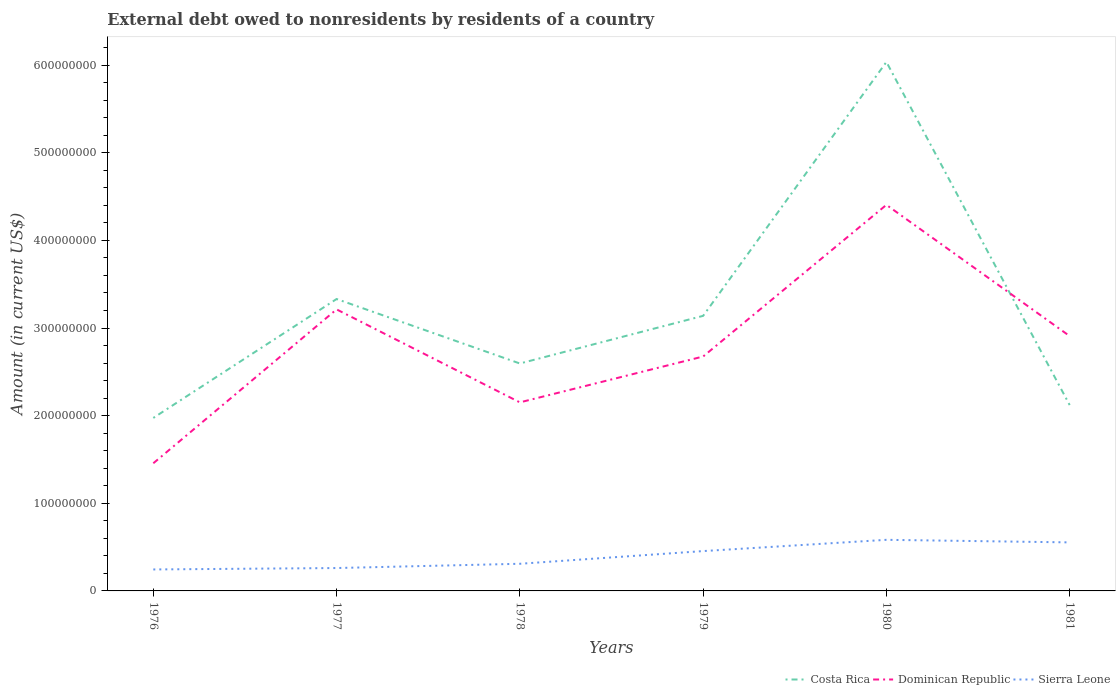Does the line corresponding to Dominican Republic intersect with the line corresponding to Costa Rica?
Keep it short and to the point. Yes. Is the number of lines equal to the number of legend labels?
Your response must be concise. Yes. Across all years, what is the maximum external debt owed by residents in Costa Rica?
Your answer should be compact. 1.97e+08. In which year was the external debt owed by residents in Costa Rica maximum?
Your answer should be compact. 1976. What is the total external debt owed by residents in Sierra Leone in the graph?
Provide a short and direct response. -1.28e+07. What is the difference between the highest and the second highest external debt owed by residents in Dominican Republic?
Provide a short and direct response. 2.95e+08. How many years are there in the graph?
Provide a short and direct response. 6. What is the difference between two consecutive major ticks on the Y-axis?
Your response must be concise. 1.00e+08. Are the values on the major ticks of Y-axis written in scientific E-notation?
Provide a short and direct response. No. Does the graph contain any zero values?
Offer a very short reply. No. Does the graph contain grids?
Give a very brief answer. No. How many legend labels are there?
Your answer should be very brief. 3. How are the legend labels stacked?
Provide a succinct answer. Horizontal. What is the title of the graph?
Provide a succinct answer. External debt owed to nonresidents by residents of a country. Does "Barbados" appear as one of the legend labels in the graph?
Provide a succinct answer. No. What is the label or title of the Y-axis?
Provide a short and direct response. Amount (in current US$). What is the Amount (in current US$) of Costa Rica in 1976?
Keep it short and to the point. 1.97e+08. What is the Amount (in current US$) in Dominican Republic in 1976?
Make the answer very short. 1.46e+08. What is the Amount (in current US$) of Sierra Leone in 1976?
Provide a short and direct response. 2.45e+07. What is the Amount (in current US$) in Costa Rica in 1977?
Offer a terse response. 3.33e+08. What is the Amount (in current US$) in Dominican Republic in 1977?
Your response must be concise. 3.21e+08. What is the Amount (in current US$) in Sierra Leone in 1977?
Make the answer very short. 2.61e+07. What is the Amount (in current US$) of Costa Rica in 1978?
Offer a very short reply. 2.60e+08. What is the Amount (in current US$) of Dominican Republic in 1978?
Keep it short and to the point. 2.15e+08. What is the Amount (in current US$) of Sierra Leone in 1978?
Ensure brevity in your answer.  3.10e+07. What is the Amount (in current US$) of Costa Rica in 1979?
Provide a succinct answer. 3.14e+08. What is the Amount (in current US$) in Dominican Republic in 1979?
Give a very brief answer. 2.68e+08. What is the Amount (in current US$) of Sierra Leone in 1979?
Your answer should be very brief. 4.55e+07. What is the Amount (in current US$) in Costa Rica in 1980?
Make the answer very short. 6.04e+08. What is the Amount (in current US$) of Dominican Republic in 1980?
Keep it short and to the point. 4.41e+08. What is the Amount (in current US$) in Sierra Leone in 1980?
Your response must be concise. 5.83e+07. What is the Amount (in current US$) in Costa Rica in 1981?
Your answer should be very brief. 2.12e+08. What is the Amount (in current US$) in Dominican Republic in 1981?
Give a very brief answer. 2.91e+08. What is the Amount (in current US$) of Sierra Leone in 1981?
Ensure brevity in your answer.  5.54e+07. Across all years, what is the maximum Amount (in current US$) in Costa Rica?
Offer a very short reply. 6.04e+08. Across all years, what is the maximum Amount (in current US$) of Dominican Republic?
Your answer should be compact. 4.41e+08. Across all years, what is the maximum Amount (in current US$) in Sierra Leone?
Your response must be concise. 5.83e+07. Across all years, what is the minimum Amount (in current US$) of Costa Rica?
Make the answer very short. 1.97e+08. Across all years, what is the minimum Amount (in current US$) in Dominican Republic?
Your answer should be compact. 1.46e+08. Across all years, what is the minimum Amount (in current US$) of Sierra Leone?
Make the answer very short. 2.45e+07. What is the total Amount (in current US$) of Costa Rica in the graph?
Keep it short and to the point. 1.92e+09. What is the total Amount (in current US$) of Dominican Republic in the graph?
Provide a short and direct response. 1.68e+09. What is the total Amount (in current US$) of Sierra Leone in the graph?
Your answer should be very brief. 2.41e+08. What is the difference between the Amount (in current US$) of Costa Rica in 1976 and that in 1977?
Offer a terse response. -1.36e+08. What is the difference between the Amount (in current US$) in Dominican Republic in 1976 and that in 1977?
Your answer should be compact. -1.76e+08. What is the difference between the Amount (in current US$) in Sierra Leone in 1976 and that in 1977?
Give a very brief answer. -1.61e+06. What is the difference between the Amount (in current US$) of Costa Rica in 1976 and that in 1978?
Ensure brevity in your answer.  -6.21e+07. What is the difference between the Amount (in current US$) of Dominican Republic in 1976 and that in 1978?
Provide a short and direct response. -6.95e+07. What is the difference between the Amount (in current US$) of Sierra Leone in 1976 and that in 1978?
Your response must be concise. -6.47e+06. What is the difference between the Amount (in current US$) in Costa Rica in 1976 and that in 1979?
Offer a terse response. -1.16e+08. What is the difference between the Amount (in current US$) of Dominican Republic in 1976 and that in 1979?
Your answer should be compact. -1.22e+08. What is the difference between the Amount (in current US$) of Sierra Leone in 1976 and that in 1979?
Make the answer very short. -2.10e+07. What is the difference between the Amount (in current US$) of Costa Rica in 1976 and that in 1980?
Provide a short and direct response. -4.06e+08. What is the difference between the Amount (in current US$) of Dominican Republic in 1976 and that in 1980?
Give a very brief answer. -2.95e+08. What is the difference between the Amount (in current US$) in Sierra Leone in 1976 and that in 1980?
Keep it short and to the point. -3.38e+07. What is the difference between the Amount (in current US$) in Costa Rica in 1976 and that in 1981?
Give a very brief answer. -1.47e+07. What is the difference between the Amount (in current US$) in Dominican Republic in 1976 and that in 1981?
Offer a very short reply. -1.45e+08. What is the difference between the Amount (in current US$) in Sierra Leone in 1976 and that in 1981?
Provide a succinct answer. -3.09e+07. What is the difference between the Amount (in current US$) of Costa Rica in 1977 and that in 1978?
Ensure brevity in your answer.  7.36e+07. What is the difference between the Amount (in current US$) in Dominican Republic in 1977 and that in 1978?
Give a very brief answer. 1.06e+08. What is the difference between the Amount (in current US$) in Sierra Leone in 1977 and that in 1978?
Keep it short and to the point. -4.86e+06. What is the difference between the Amount (in current US$) of Costa Rica in 1977 and that in 1979?
Keep it short and to the point. 1.92e+07. What is the difference between the Amount (in current US$) in Dominican Republic in 1977 and that in 1979?
Offer a terse response. 5.38e+07. What is the difference between the Amount (in current US$) in Sierra Leone in 1977 and that in 1979?
Make the answer very short. -1.93e+07. What is the difference between the Amount (in current US$) of Costa Rica in 1977 and that in 1980?
Your answer should be very brief. -2.71e+08. What is the difference between the Amount (in current US$) of Dominican Republic in 1977 and that in 1980?
Provide a short and direct response. -1.19e+08. What is the difference between the Amount (in current US$) in Sierra Leone in 1977 and that in 1980?
Your answer should be compact. -3.22e+07. What is the difference between the Amount (in current US$) of Costa Rica in 1977 and that in 1981?
Offer a terse response. 1.21e+08. What is the difference between the Amount (in current US$) of Dominican Republic in 1977 and that in 1981?
Keep it short and to the point. 3.05e+07. What is the difference between the Amount (in current US$) in Sierra Leone in 1977 and that in 1981?
Make the answer very short. -2.93e+07. What is the difference between the Amount (in current US$) of Costa Rica in 1978 and that in 1979?
Make the answer very short. -5.44e+07. What is the difference between the Amount (in current US$) in Dominican Republic in 1978 and that in 1979?
Provide a succinct answer. -5.23e+07. What is the difference between the Amount (in current US$) in Sierra Leone in 1978 and that in 1979?
Your response must be concise. -1.45e+07. What is the difference between the Amount (in current US$) in Costa Rica in 1978 and that in 1980?
Provide a short and direct response. -3.44e+08. What is the difference between the Amount (in current US$) of Dominican Republic in 1978 and that in 1980?
Keep it short and to the point. -2.25e+08. What is the difference between the Amount (in current US$) in Sierra Leone in 1978 and that in 1980?
Give a very brief answer. -2.73e+07. What is the difference between the Amount (in current US$) of Costa Rica in 1978 and that in 1981?
Make the answer very short. 4.74e+07. What is the difference between the Amount (in current US$) of Dominican Republic in 1978 and that in 1981?
Your answer should be very brief. -7.56e+07. What is the difference between the Amount (in current US$) of Sierra Leone in 1978 and that in 1981?
Provide a succinct answer. -2.44e+07. What is the difference between the Amount (in current US$) in Costa Rica in 1979 and that in 1980?
Keep it short and to the point. -2.90e+08. What is the difference between the Amount (in current US$) in Dominican Republic in 1979 and that in 1980?
Provide a succinct answer. -1.73e+08. What is the difference between the Amount (in current US$) of Sierra Leone in 1979 and that in 1980?
Ensure brevity in your answer.  -1.28e+07. What is the difference between the Amount (in current US$) in Costa Rica in 1979 and that in 1981?
Your answer should be very brief. 1.02e+08. What is the difference between the Amount (in current US$) of Dominican Republic in 1979 and that in 1981?
Give a very brief answer. -2.33e+07. What is the difference between the Amount (in current US$) in Sierra Leone in 1979 and that in 1981?
Keep it short and to the point. -9.92e+06. What is the difference between the Amount (in current US$) in Costa Rica in 1980 and that in 1981?
Give a very brief answer. 3.92e+08. What is the difference between the Amount (in current US$) in Dominican Republic in 1980 and that in 1981?
Your answer should be compact. 1.50e+08. What is the difference between the Amount (in current US$) in Sierra Leone in 1980 and that in 1981?
Your response must be concise. 2.93e+06. What is the difference between the Amount (in current US$) in Costa Rica in 1976 and the Amount (in current US$) in Dominican Republic in 1977?
Provide a short and direct response. -1.24e+08. What is the difference between the Amount (in current US$) in Costa Rica in 1976 and the Amount (in current US$) in Sierra Leone in 1977?
Offer a terse response. 1.71e+08. What is the difference between the Amount (in current US$) in Dominican Republic in 1976 and the Amount (in current US$) in Sierra Leone in 1977?
Keep it short and to the point. 1.20e+08. What is the difference between the Amount (in current US$) in Costa Rica in 1976 and the Amount (in current US$) in Dominican Republic in 1978?
Provide a succinct answer. -1.78e+07. What is the difference between the Amount (in current US$) in Costa Rica in 1976 and the Amount (in current US$) in Sierra Leone in 1978?
Make the answer very short. 1.66e+08. What is the difference between the Amount (in current US$) of Dominican Republic in 1976 and the Amount (in current US$) of Sierra Leone in 1978?
Provide a succinct answer. 1.15e+08. What is the difference between the Amount (in current US$) in Costa Rica in 1976 and the Amount (in current US$) in Dominican Republic in 1979?
Provide a succinct answer. -7.01e+07. What is the difference between the Amount (in current US$) in Costa Rica in 1976 and the Amount (in current US$) in Sierra Leone in 1979?
Keep it short and to the point. 1.52e+08. What is the difference between the Amount (in current US$) of Dominican Republic in 1976 and the Amount (in current US$) of Sierra Leone in 1979?
Give a very brief answer. 1.00e+08. What is the difference between the Amount (in current US$) in Costa Rica in 1976 and the Amount (in current US$) in Dominican Republic in 1980?
Provide a succinct answer. -2.43e+08. What is the difference between the Amount (in current US$) in Costa Rica in 1976 and the Amount (in current US$) in Sierra Leone in 1980?
Offer a very short reply. 1.39e+08. What is the difference between the Amount (in current US$) in Dominican Republic in 1976 and the Amount (in current US$) in Sierra Leone in 1980?
Ensure brevity in your answer.  8.74e+07. What is the difference between the Amount (in current US$) of Costa Rica in 1976 and the Amount (in current US$) of Dominican Republic in 1981?
Provide a succinct answer. -9.34e+07. What is the difference between the Amount (in current US$) in Costa Rica in 1976 and the Amount (in current US$) in Sierra Leone in 1981?
Provide a short and direct response. 1.42e+08. What is the difference between the Amount (in current US$) in Dominican Republic in 1976 and the Amount (in current US$) in Sierra Leone in 1981?
Offer a terse response. 9.03e+07. What is the difference between the Amount (in current US$) of Costa Rica in 1977 and the Amount (in current US$) of Dominican Republic in 1978?
Your response must be concise. 1.18e+08. What is the difference between the Amount (in current US$) of Costa Rica in 1977 and the Amount (in current US$) of Sierra Leone in 1978?
Provide a short and direct response. 3.02e+08. What is the difference between the Amount (in current US$) in Dominican Republic in 1977 and the Amount (in current US$) in Sierra Leone in 1978?
Offer a terse response. 2.90e+08. What is the difference between the Amount (in current US$) of Costa Rica in 1977 and the Amount (in current US$) of Dominican Republic in 1979?
Your answer should be compact. 6.56e+07. What is the difference between the Amount (in current US$) of Costa Rica in 1977 and the Amount (in current US$) of Sierra Leone in 1979?
Offer a terse response. 2.88e+08. What is the difference between the Amount (in current US$) in Dominican Republic in 1977 and the Amount (in current US$) in Sierra Leone in 1979?
Give a very brief answer. 2.76e+08. What is the difference between the Amount (in current US$) of Costa Rica in 1977 and the Amount (in current US$) of Dominican Republic in 1980?
Make the answer very short. -1.07e+08. What is the difference between the Amount (in current US$) of Costa Rica in 1977 and the Amount (in current US$) of Sierra Leone in 1980?
Your answer should be very brief. 2.75e+08. What is the difference between the Amount (in current US$) in Dominican Republic in 1977 and the Amount (in current US$) in Sierra Leone in 1980?
Give a very brief answer. 2.63e+08. What is the difference between the Amount (in current US$) in Costa Rica in 1977 and the Amount (in current US$) in Dominican Republic in 1981?
Your response must be concise. 4.23e+07. What is the difference between the Amount (in current US$) in Costa Rica in 1977 and the Amount (in current US$) in Sierra Leone in 1981?
Provide a succinct answer. 2.78e+08. What is the difference between the Amount (in current US$) of Dominican Republic in 1977 and the Amount (in current US$) of Sierra Leone in 1981?
Provide a short and direct response. 2.66e+08. What is the difference between the Amount (in current US$) in Costa Rica in 1978 and the Amount (in current US$) in Dominican Republic in 1979?
Offer a very short reply. -7.96e+06. What is the difference between the Amount (in current US$) of Costa Rica in 1978 and the Amount (in current US$) of Sierra Leone in 1979?
Your answer should be very brief. 2.14e+08. What is the difference between the Amount (in current US$) in Dominican Republic in 1978 and the Amount (in current US$) in Sierra Leone in 1979?
Your answer should be very brief. 1.70e+08. What is the difference between the Amount (in current US$) of Costa Rica in 1978 and the Amount (in current US$) of Dominican Republic in 1980?
Your response must be concise. -1.81e+08. What is the difference between the Amount (in current US$) in Costa Rica in 1978 and the Amount (in current US$) in Sierra Leone in 1980?
Offer a terse response. 2.01e+08. What is the difference between the Amount (in current US$) in Dominican Republic in 1978 and the Amount (in current US$) in Sierra Leone in 1980?
Provide a succinct answer. 1.57e+08. What is the difference between the Amount (in current US$) in Costa Rica in 1978 and the Amount (in current US$) in Dominican Republic in 1981?
Your response must be concise. -3.13e+07. What is the difference between the Amount (in current US$) of Costa Rica in 1978 and the Amount (in current US$) of Sierra Leone in 1981?
Provide a succinct answer. 2.04e+08. What is the difference between the Amount (in current US$) in Dominican Republic in 1978 and the Amount (in current US$) in Sierra Leone in 1981?
Offer a very short reply. 1.60e+08. What is the difference between the Amount (in current US$) of Costa Rica in 1979 and the Amount (in current US$) of Dominican Republic in 1980?
Offer a terse response. -1.27e+08. What is the difference between the Amount (in current US$) in Costa Rica in 1979 and the Amount (in current US$) in Sierra Leone in 1980?
Keep it short and to the point. 2.56e+08. What is the difference between the Amount (in current US$) in Dominican Republic in 1979 and the Amount (in current US$) in Sierra Leone in 1980?
Give a very brief answer. 2.09e+08. What is the difference between the Amount (in current US$) of Costa Rica in 1979 and the Amount (in current US$) of Dominican Republic in 1981?
Your answer should be compact. 2.31e+07. What is the difference between the Amount (in current US$) in Costa Rica in 1979 and the Amount (in current US$) in Sierra Leone in 1981?
Offer a terse response. 2.59e+08. What is the difference between the Amount (in current US$) in Dominican Republic in 1979 and the Amount (in current US$) in Sierra Leone in 1981?
Ensure brevity in your answer.  2.12e+08. What is the difference between the Amount (in current US$) in Costa Rica in 1980 and the Amount (in current US$) in Dominican Republic in 1981?
Offer a very short reply. 3.13e+08. What is the difference between the Amount (in current US$) in Costa Rica in 1980 and the Amount (in current US$) in Sierra Leone in 1981?
Offer a terse response. 5.48e+08. What is the difference between the Amount (in current US$) of Dominican Republic in 1980 and the Amount (in current US$) of Sierra Leone in 1981?
Offer a very short reply. 3.85e+08. What is the average Amount (in current US$) in Costa Rica per year?
Make the answer very short. 3.20e+08. What is the average Amount (in current US$) of Dominican Republic per year?
Make the answer very short. 2.80e+08. What is the average Amount (in current US$) of Sierra Leone per year?
Offer a terse response. 4.01e+07. In the year 1976, what is the difference between the Amount (in current US$) of Costa Rica and Amount (in current US$) of Dominican Republic?
Make the answer very short. 5.17e+07. In the year 1976, what is the difference between the Amount (in current US$) in Costa Rica and Amount (in current US$) in Sierra Leone?
Ensure brevity in your answer.  1.73e+08. In the year 1976, what is the difference between the Amount (in current US$) in Dominican Republic and Amount (in current US$) in Sierra Leone?
Keep it short and to the point. 1.21e+08. In the year 1977, what is the difference between the Amount (in current US$) of Costa Rica and Amount (in current US$) of Dominican Republic?
Ensure brevity in your answer.  1.18e+07. In the year 1977, what is the difference between the Amount (in current US$) of Costa Rica and Amount (in current US$) of Sierra Leone?
Make the answer very short. 3.07e+08. In the year 1977, what is the difference between the Amount (in current US$) of Dominican Republic and Amount (in current US$) of Sierra Leone?
Offer a very short reply. 2.95e+08. In the year 1978, what is the difference between the Amount (in current US$) of Costa Rica and Amount (in current US$) of Dominican Republic?
Offer a terse response. 4.44e+07. In the year 1978, what is the difference between the Amount (in current US$) of Costa Rica and Amount (in current US$) of Sierra Leone?
Keep it short and to the point. 2.29e+08. In the year 1978, what is the difference between the Amount (in current US$) in Dominican Republic and Amount (in current US$) in Sierra Leone?
Offer a terse response. 1.84e+08. In the year 1979, what is the difference between the Amount (in current US$) in Costa Rica and Amount (in current US$) in Dominican Republic?
Give a very brief answer. 4.64e+07. In the year 1979, what is the difference between the Amount (in current US$) of Costa Rica and Amount (in current US$) of Sierra Leone?
Your answer should be compact. 2.68e+08. In the year 1979, what is the difference between the Amount (in current US$) of Dominican Republic and Amount (in current US$) of Sierra Leone?
Keep it short and to the point. 2.22e+08. In the year 1980, what is the difference between the Amount (in current US$) of Costa Rica and Amount (in current US$) of Dominican Republic?
Give a very brief answer. 1.63e+08. In the year 1980, what is the difference between the Amount (in current US$) in Costa Rica and Amount (in current US$) in Sierra Leone?
Provide a succinct answer. 5.45e+08. In the year 1980, what is the difference between the Amount (in current US$) in Dominican Republic and Amount (in current US$) in Sierra Leone?
Your response must be concise. 3.82e+08. In the year 1981, what is the difference between the Amount (in current US$) in Costa Rica and Amount (in current US$) in Dominican Republic?
Give a very brief answer. -7.87e+07. In the year 1981, what is the difference between the Amount (in current US$) of Costa Rica and Amount (in current US$) of Sierra Leone?
Your answer should be compact. 1.57e+08. In the year 1981, what is the difference between the Amount (in current US$) of Dominican Republic and Amount (in current US$) of Sierra Leone?
Ensure brevity in your answer.  2.35e+08. What is the ratio of the Amount (in current US$) of Costa Rica in 1976 to that in 1977?
Offer a terse response. 0.59. What is the ratio of the Amount (in current US$) of Dominican Republic in 1976 to that in 1977?
Provide a short and direct response. 0.45. What is the ratio of the Amount (in current US$) in Sierra Leone in 1976 to that in 1977?
Provide a succinct answer. 0.94. What is the ratio of the Amount (in current US$) of Costa Rica in 1976 to that in 1978?
Give a very brief answer. 0.76. What is the ratio of the Amount (in current US$) of Dominican Republic in 1976 to that in 1978?
Provide a short and direct response. 0.68. What is the ratio of the Amount (in current US$) in Sierra Leone in 1976 to that in 1978?
Your answer should be very brief. 0.79. What is the ratio of the Amount (in current US$) in Costa Rica in 1976 to that in 1979?
Your answer should be compact. 0.63. What is the ratio of the Amount (in current US$) of Dominican Republic in 1976 to that in 1979?
Your answer should be compact. 0.54. What is the ratio of the Amount (in current US$) in Sierra Leone in 1976 to that in 1979?
Ensure brevity in your answer.  0.54. What is the ratio of the Amount (in current US$) of Costa Rica in 1976 to that in 1980?
Your answer should be compact. 0.33. What is the ratio of the Amount (in current US$) of Dominican Republic in 1976 to that in 1980?
Make the answer very short. 0.33. What is the ratio of the Amount (in current US$) in Sierra Leone in 1976 to that in 1980?
Give a very brief answer. 0.42. What is the ratio of the Amount (in current US$) in Costa Rica in 1976 to that in 1981?
Your answer should be compact. 0.93. What is the ratio of the Amount (in current US$) of Dominican Republic in 1976 to that in 1981?
Your response must be concise. 0.5. What is the ratio of the Amount (in current US$) of Sierra Leone in 1976 to that in 1981?
Offer a very short reply. 0.44. What is the ratio of the Amount (in current US$) of Costa Rica in 1977 to that in 1978?
Keep it short and to the point. 1.28. What is the ratio of the Amount (in current US$) of Dominican Republic in 1977 to that in 1978?
Offer a very short reply. 1.49. What is the ratio of the Amount (in current US$) of Sierra Leone in 1977 to that in 1978?
Offer a very short reply. 0.84. What is the ratio of the Amount (in current US$) in Costa Rica in 1977 to that in 1979?
Keep it short and to the point. 1.06. What is the ratio of the Amount (in current US$) in Dominican Republic in 1977 to that in 1979?
Offer a terse response. 1.2. What is the ratio of the Amount (in current US$) in Sierra Leone in 1977 to that in 1979?
Your response must be concise. 0.57. What is the ratio of the Amount (in current US$) in Costa Rica in 1977 to that in 1980?
Provide a succinct answer. 0.55. What is the ratio of the Amount (in current US$) of Dominican Republic in 1977 to that in 1980?
Offer a very short reply. 0.73. What is the ratio of the Amount (in current US$) in Sierra Leone in 1977 to that in 1980?
Provide a succinct answer. 0.45. What is the ratio of the Amount (in current US$) in Costa Rica in 1977 to that in 1981?
Make the answer very short. 1.57. What is the ratio of the Amount (in current US$) of Dominican Republic in 1977 to that in 1981?
Give a very brief answer. 1.1. What is the ratio of the Amount (in current US$) of Sierra Leone in 1977 to that in 1981?
Provide a succinct answer. 0.47. What is the ratio of the Amount (in current US$) in Costa Rica in 1978 to that in 1979?
Offer a very short reply. 0.83. What is the ratio of the Amount (in current US$) of Dominican Republic in 1978 to that in 1979?
Offer a very short reply. 0.8. What is the ratio of the Amount (in current US$) of Sierra Leone in 1978 to that in 1979?
Offer a terse response. 0.68. What is the ratio of the Amount (in current US$) of Costa Rica in 1978 to that in 1980?
Offer a terse response. 0.43. What is the ratio of the Amount (in current US$) of Dominican Republic in 1978 to that in 1980?
Your answer should be compact. 0.49. What is the ratio of the Amount (in current US$) in Sierra Leone in 1978 to that in 1980?
Make the answer very short. 0.53. What is the ratio of the Amount (in current US$) of Costa Rica in 1978 to that in 1981?
Give a very brief answer. 1.22. What is the ratio of the Amount (in current US$) of Dominican Republic in 1978 to that in 1981?
Your response must be concise. 0.74. What is the ratio of the Amount (in current US$) of Sierra Leone in 1978 to that in 1981?
Offer a terse response. 0.56. What is the ratio of the Amount (in current US$) of Costa Rica in 1979 to that in 1980?
Your response must be concise. 0.52. What is the ratio of the Amount (in current US$) in Dominican Republic in 1979 to that in 1980?
Keep it short and to the point. 0.61. What is the ratio of the Amount (in current US$) of Sierra Leone in 1979 to that in 1980?
Your response must be concise. 0.78. What is the ratio of the Amount (in current US$) of Costa Rica in 1979 to that in 1981?
Give a very brief answer. 1.48. What is the ratio of the Amount (in current US$) in Dominican Republic in 1979 to that in 1981?
Keep it short and to the point. 0.92. What is the ratio of the Amount (in current US$) of Sierra Leone in 1979 to that in 1981?
Give a very brief answer. 0.82. What is the ratio of the Amount (in current US$) of Costa Rica in 1980 to that in 1981?
Your response must be concise. 2.85. What is the ratio of the Amount (in current US$) in Dominican Republic in 1980 to that in 1981?
Keep it short and to the point. 1.51. What is the ratio of the Amount (in current US$) in Sierra Leone in 1980 to that in 1981?
Your response must be concise. 1.05. What is the difference between the highest and the second highest Amount (in current US$) of Costa Rica?
Your answer should be compact. 2.71e+08. What is the difference between the highest and the second highest Amount (in current US$) of Dominican Republic?
Your answer should be compact. 1.19e+08. What is the difference between the highest and the second highest Amount (in current US$) of Sierra Leone?
Provide a short and direct response. 2.93e+06. What is the difference between the highest and the lowest Amount (in current US$) in Costa Rica?
Provide a succinct answer. 4.06e+08. What is the difference between the highest and the lowest Amount (in current US$) of Dominican Republic?
Provide a succinct answer. 2.95e+08. What is the difference between the highest and the lowest Amount (in current US$) of Sierra Leone?
Make the answer very short. 3.38e+07. 